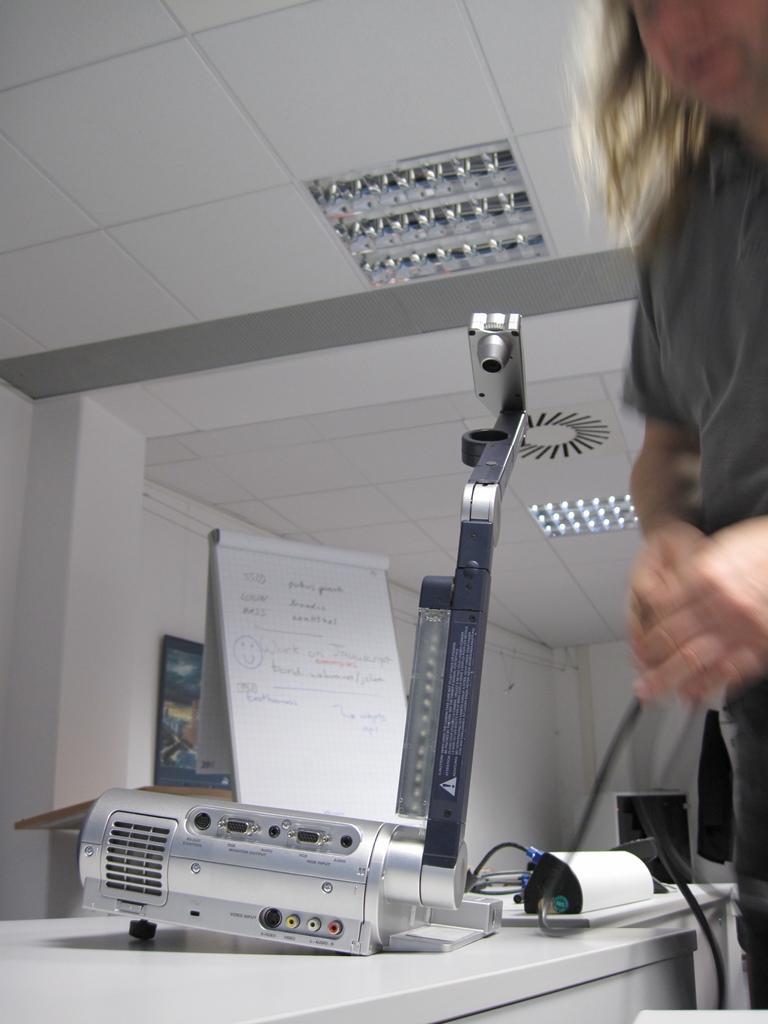Could you give a brief overview of what you see in this image? In this image we can see a person is standing, in front here is the table, and some objects on it, here is the white board, here is the wire, here are the lights, at above here is the roof. 